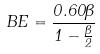<formula> <loc_0><loc_0><loc_500><loc_500>B E = \frac { 0 . 6 0 \beta } { 1 - \frac { \beta } { 2 } }</formula> 